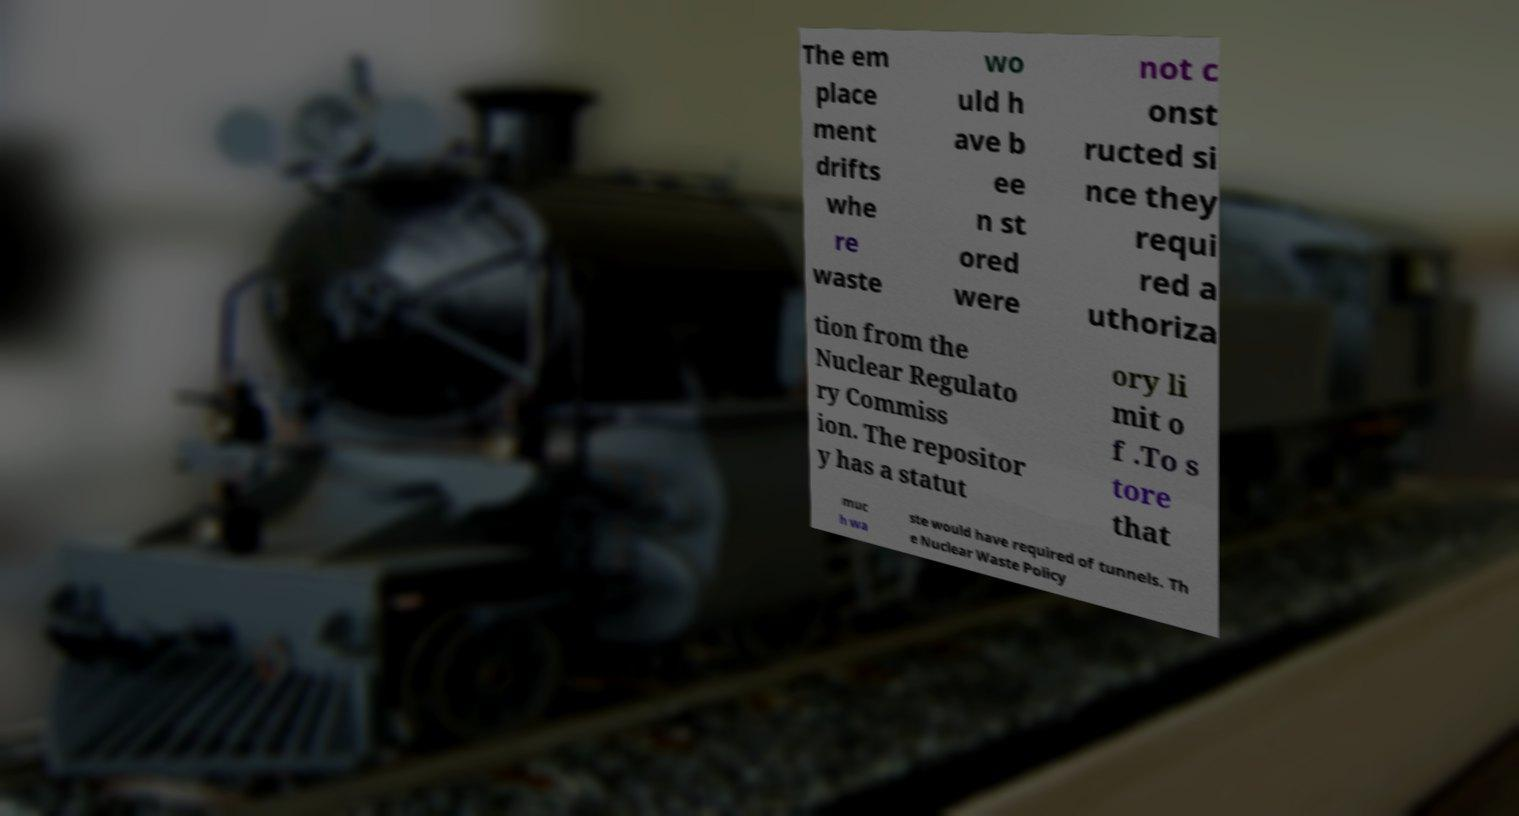There's text embedded in this image that I need extracted. Can you transcribe it verbatim? The em place ment drifts whe re waste wo uld h ave b ee n st ored were not c onst ructed si nce they requi red a uthoriza tion from the Nuclear Regulato ry Commiss ion. The repositor y has a statut ory li mit o f .To s tore that muc h wa ste would have required of tunnels. Th e Nuclear Waste Policy 